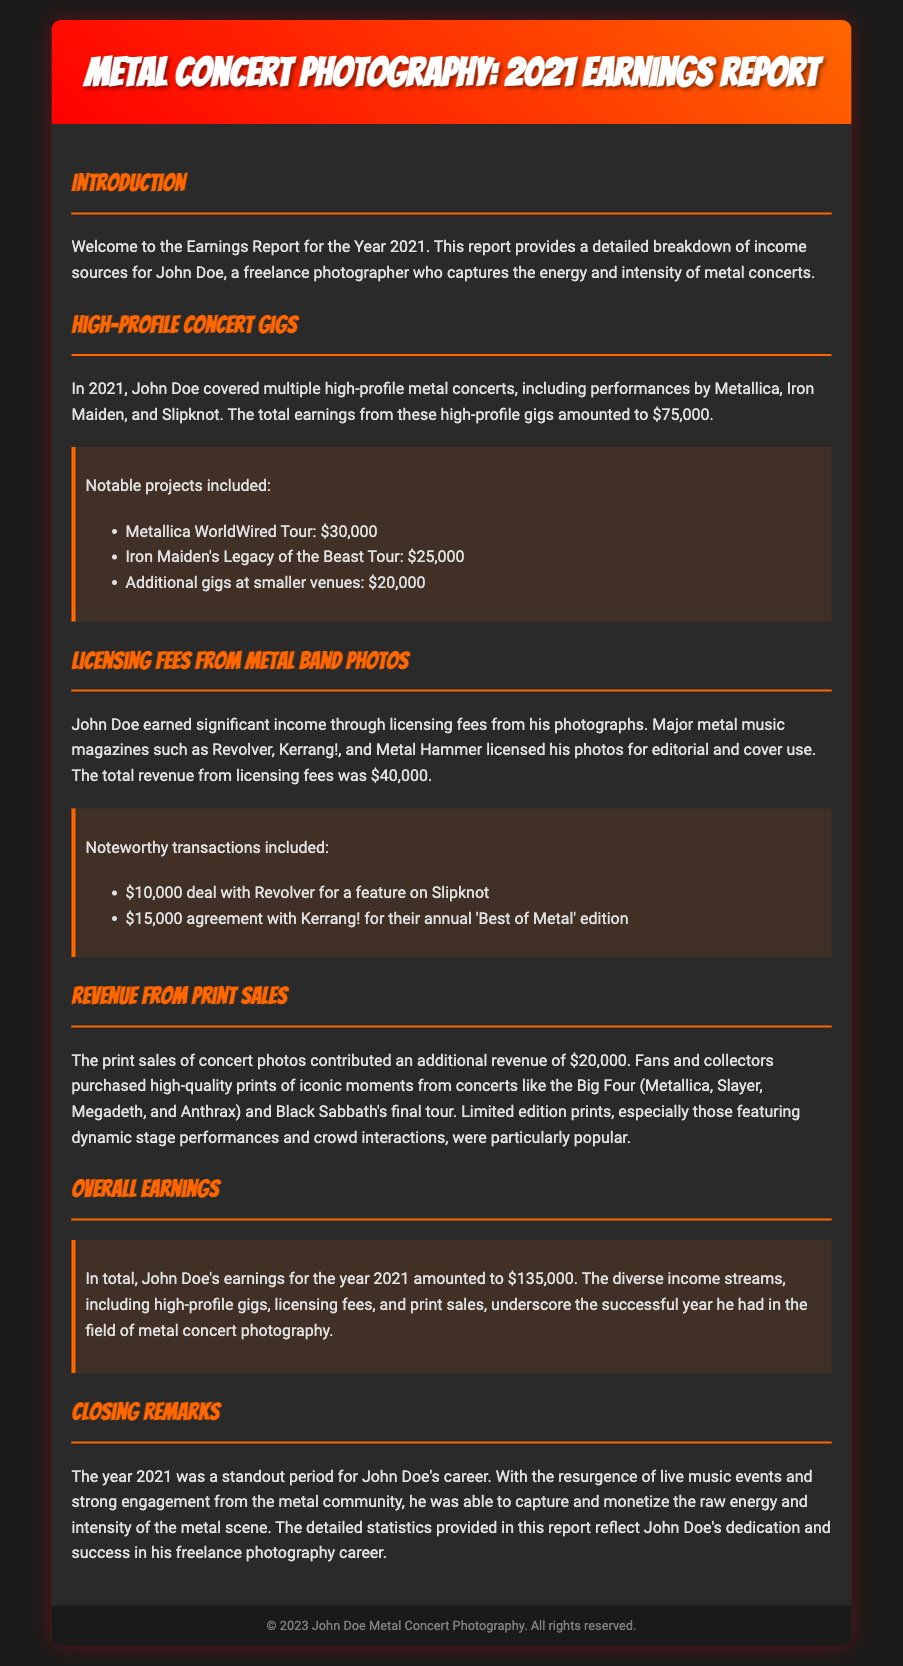What is the total earnings for 2021? The total earnings are specified in the document as the sum of all income sources, which is $135,000.
Answer: $135,000 What was the revenue from licensing fees? The revenue from licensing fees is clearly stated as $40,000 in the earnings report.
Answer: $40,000 Name one high-profile band John Doe photographed. The document lists multiple bands, including Metallica as a high-profile band.
Answer: Metallica How much did John Doe earn from the Metallica WorldWired Tour? The document provides a specific amount for this gig, which is stated as $30,000.
Answer: $30,000 What was the revenue from print sales? A specific revenue figure from print sales is mentioned, which totals $20,000.
Answer: $20,000 How much did he earn from Kerrang! for the annual edition? The document mentions that he earned $15,000 from Kerrang! for their annual 'Best of Metal' edition.
Answer: $15,000 Which concert event's photos sold well as prints? The document highlights iconic moments from the Big Four concert as popular prints.
Answer: Big Four What is highlighted as a key factor for John Doe's successful year? The report emphasizes the resurgence of live music events as a key factor for success.
Answer: Resurgence of live music events Which concert tours did John Doe cover in 2021? The document lists several tours, including Iron Maiden's Legacy of the Beast Tour as one covered in 2021.
Answer: Iron Maiden's Legacy of the Beast Tour 